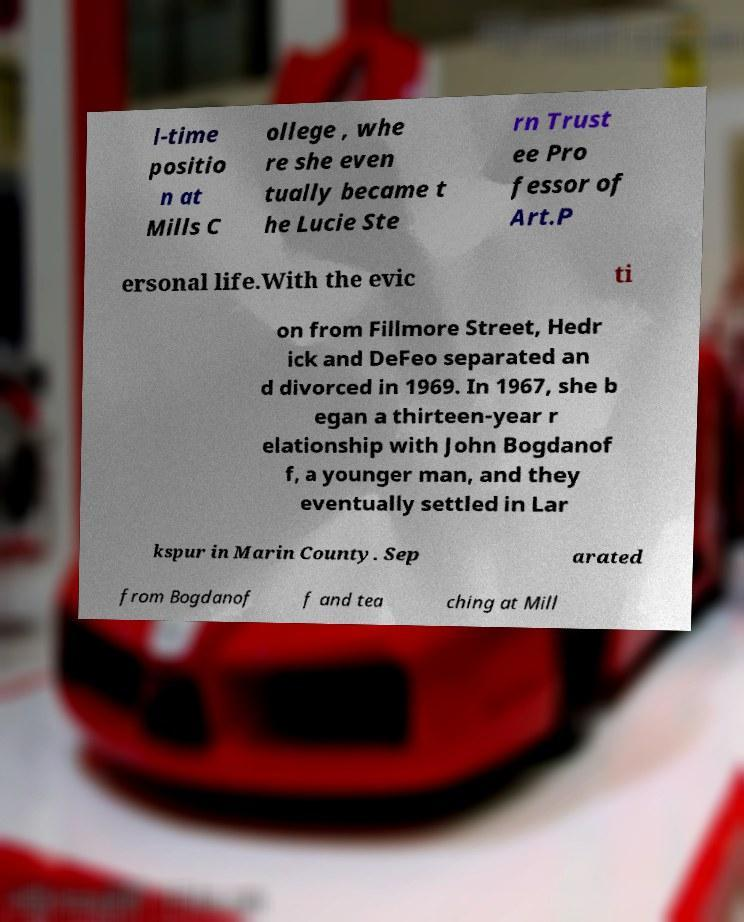Could you extract and type out the text from this image? l-time positio n at Mills C ollege , whe re she even tually became t he Lucie Ste rn Trust ee Pro fessor of Art.P ersonal life.With the evic ti on from Fillmore Street, Hedr ick and DeFeo separated an d divorced in 1969. In 1967, she b egan a thirteen-year r elationship with John Bogdanof f, a younger man, and they eventually settled in Lar kspur in Marin County. Sep arated from Bogdanof f and tea ching at Mill 